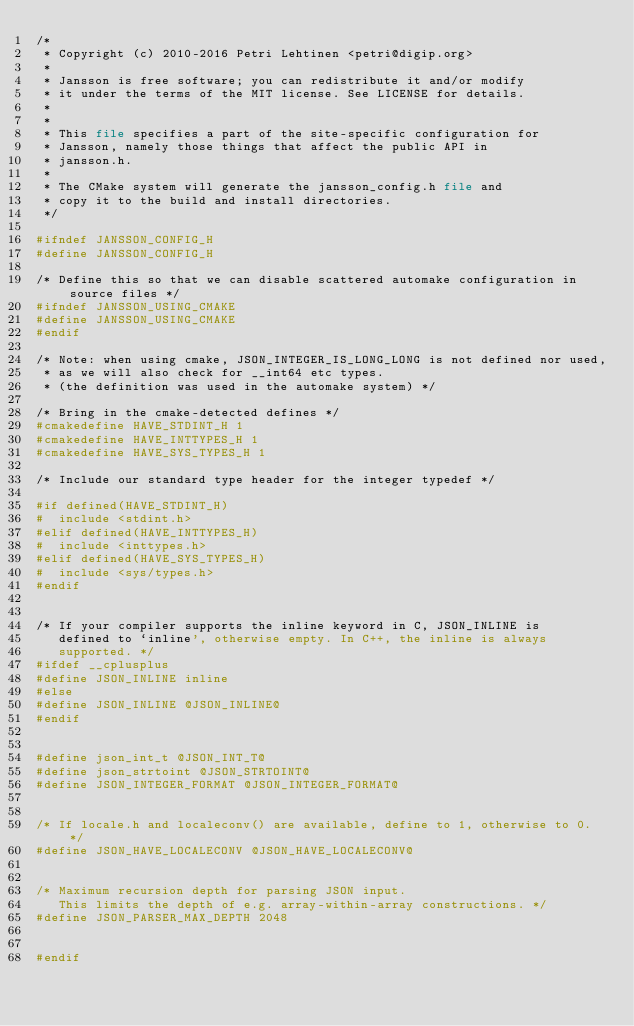Convert code to text. <code><loc_0><loc_0><loc_500><loc_500><_CMake_>/*
 * Copyright (c) 2010-2016 Petri Lehtinen <petri@digip.org>
 *
 * Jansson is free software; you can redistribute it and/or modify
 * it under the terms of the MIT license. See LICENSE for details.
 *
 *
 * This file specifies a part of the site-specific configuration for
 * Jansson, namely those things that affect the public API in
 * jansson.h.
 *
 * The CMake system will generate the jansson_config.h file and
 * copy it to the build and install directories.
 */

#ifndef JANSSON_CONFIG_H
#define JANSSON_CONFIG_H

/* Define this so that we can disable scattered automake configuration in source files */
#ifndef JANSSON_USING_CMAKE
#define JANSSON_USING_CMAKE
#endif

/* Note: when using cmake, JSON_INTEGER_IS_LONG_LONG is not defined nor used,
 * as we will also check for __int64 etc types.
 * (the definition was used in the automake system) */

/* Bring in the cmake-detected defines */
#cmakedefine HAVE_STDINT_H 1
#cmakedefine HAVE_INTTYPES_H 1
#cmakedefine HAVE_SYS_TYPES_H 1

/* Include our standard type header for the integer typedef */

#if defined(HAVE_STDINT_H)
#  include <stdint.h>
#elif defined(HAVE_INTTYPES_H)
#  include <inttypes.h>
#elif defined(HAVE_SYS_TYPES_H)
#  include <sys/types.h>
#endif


/* If your compiler supports the inline keyword in C, JSON_INLINE is
   defined to `inline', otherwise empty. In C++, the inline is always
   supported. */
#ifdef __cplusplus
#define JSON_INLINE inline
#else
#define JSON_INLINE @JSON_INLINE@
#endif


#define json_int_t @JSON_INT_T@
#define json_strtoint @JSON_STRTOINT@
#define JSON_INTEGER_FORMAT @JSON_INTEGER_FORMAT@


/* If locale.h and localeconv() are available, define to 1, otherwise to 0. */
#define JSON_HAVE_LOCALECONV @JSON_HAVE_LOCALECONV@


/* Maximum recursion depth for parsing JSON input.
   This limits the depth of e.g. array-within-array constructions. */
#define JSON_PARSER_MAX_DEPTH 2048


#endif
</code> 